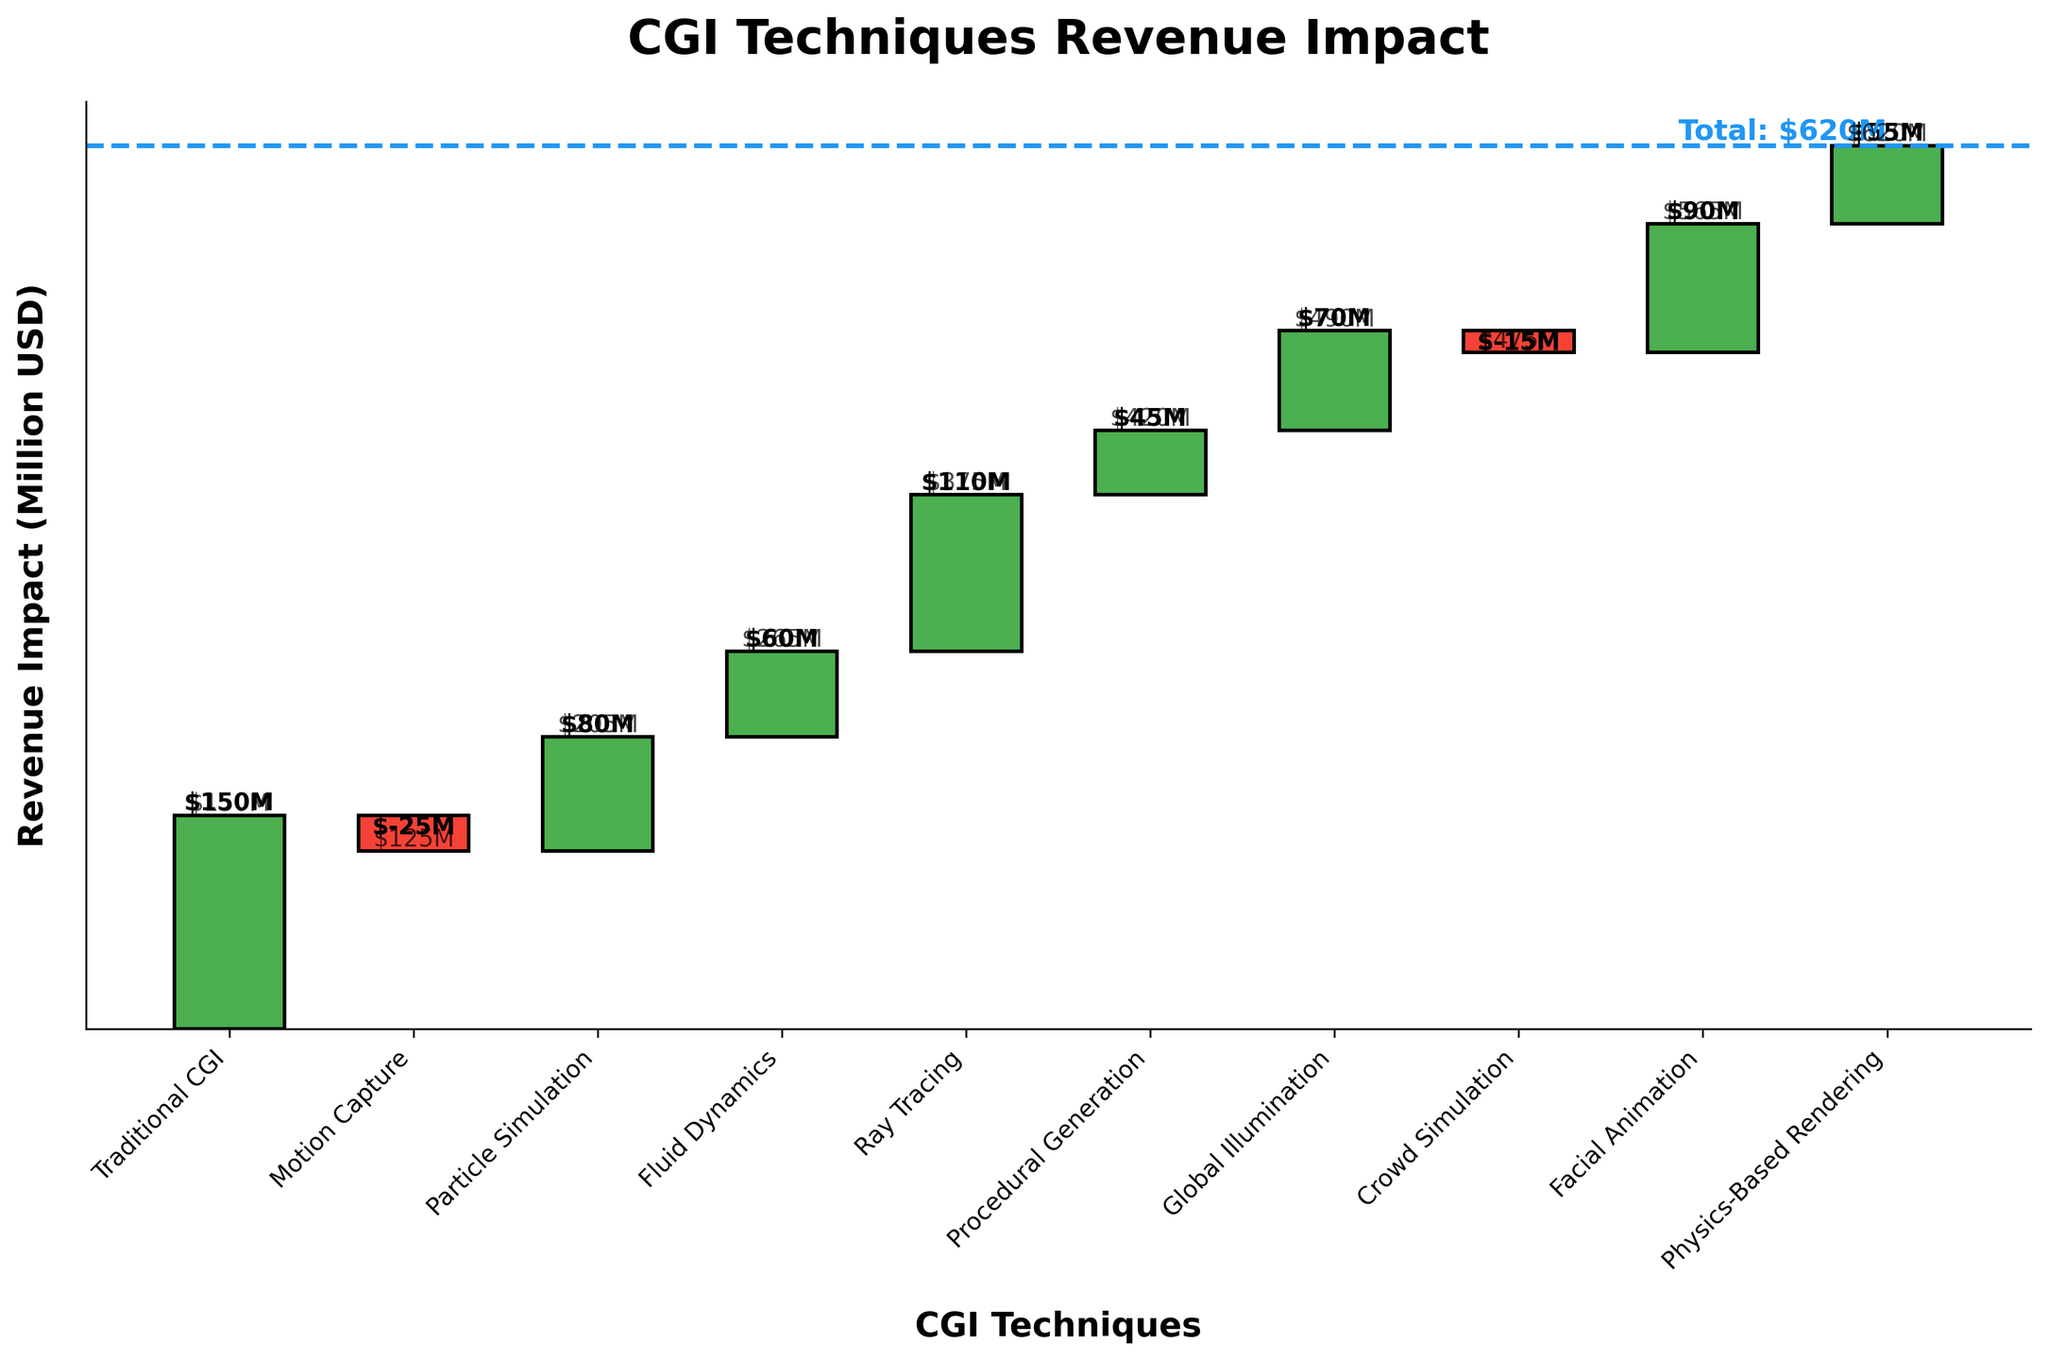What is the total revenue impact from all CGI techniques? The total revenue impact is indicated by a dashed line at the end of the chart, labeled as 'Total: $620M'.
Answer: $620M Which CGI technique contributed the most to the revenue? By looking at the height of the bars, Ray Tracing has the tallest bar, indicating it contributed the most at $110M.
Answer: Ray Tracing Which CGI technique had the smallest positive impact on revenue? Procedural Generation has a positive impact of $45M, which is the smallest among all the positive values.
Answer: Procedural Generation Which CGI techniques had a negative impact on revenue? Motion Capture and Crowd Simulation have red bars, which indicate negative values of -$25M and -$15M respectively.
Answer: Motion Capture, Crowd Simulation What is the cumulative revenue impact after the Facial Animation technique? By adding up the values sequentially from the start to Facial Animation: 150 - 25 + 80 + 60 + 110 + 45 + 70 - 15 + 90 = 565M.
Answer: $565M How much more did Ray Tracing contribute compared to Fluid Dynamics? Ray Tracing contributed $110M and Fluid Dynamics $60M. The difference is $110M - $60M.
Answer: $50M What is the cumulative revenue impact before applying Motion Capture? The cumulative revenue impact is just the value of Traditional CGI, as it's the first technique used: $150M.
Answer: $150M Between Particle Simulation and Facial Animation, which contributed more? Facial Animation contributed $90M, while Particle Simulation contributed $80M. Facial Animation is greater.
Answer: Facial Animation What percentage of the total revenue impact is attributed to Physics-Based Rendering? Physics-Based Rendering's contribution is $55M out of the total $620M. The percentage is (55 / 620) * 100.
Answer: 8.87% What is the total positive impact on revenue? Summing up all positive impacts: 150 + 80 + 60 + 110 + 45 + 70 + 90 + 55 = 660M.
Answer: $660M 